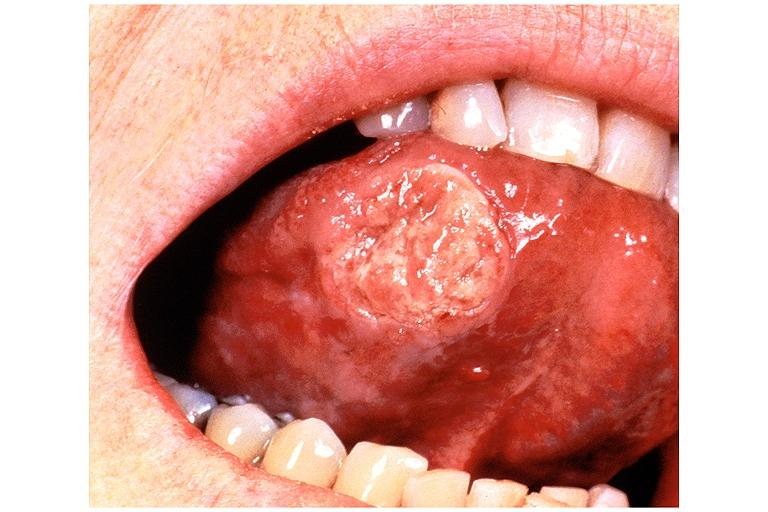does muscle atrophy show squamous cell carcinoma?
Answer the question using a single word or phrase. No 